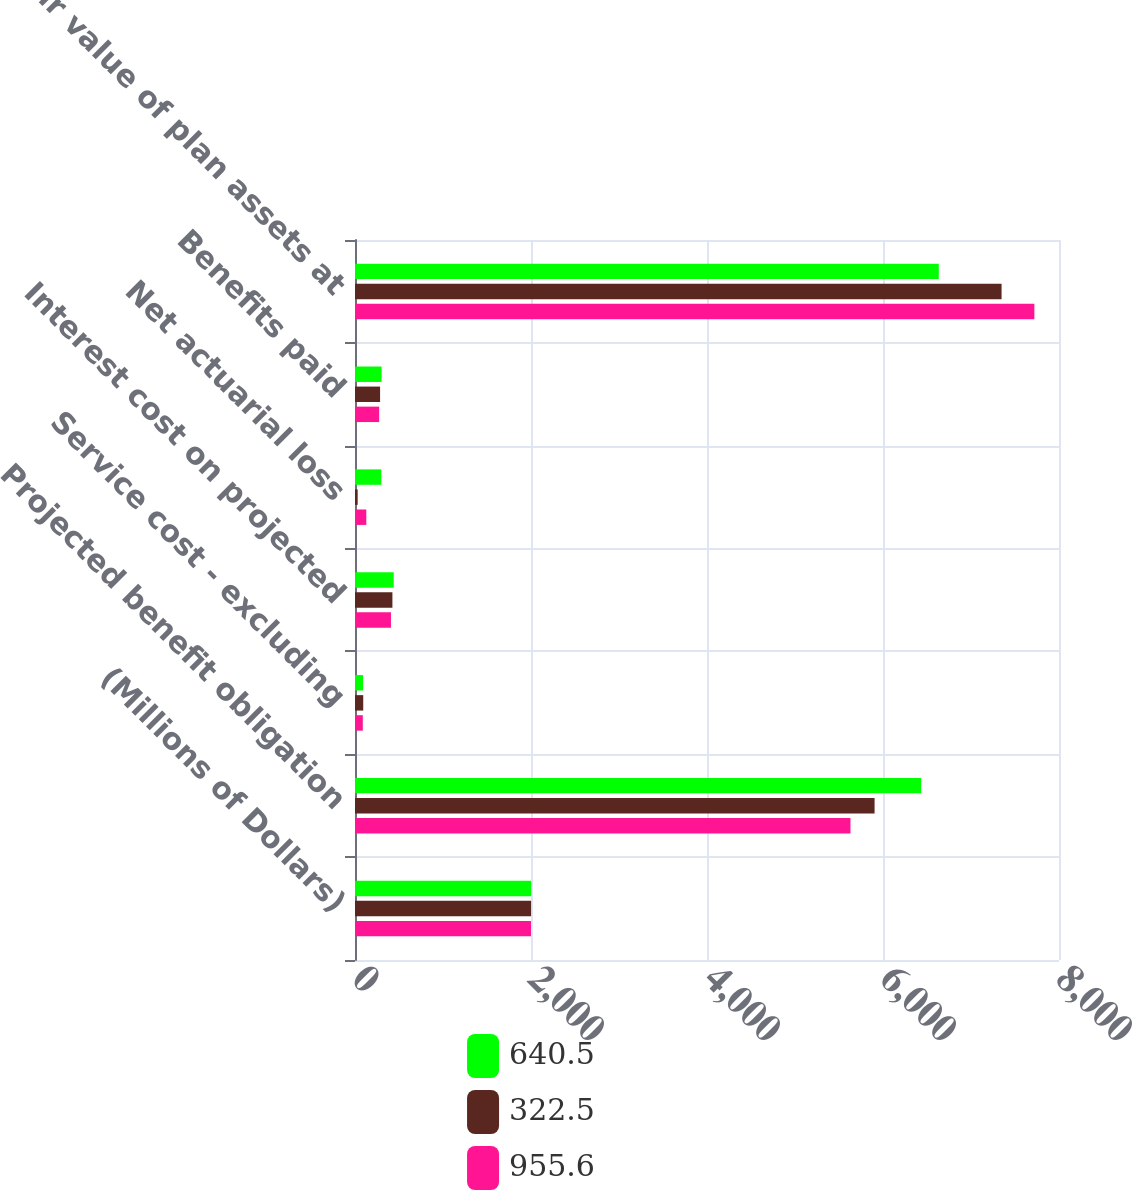Convert chart. <chart><loc_0><loc_0><loc_500><loc_500><stacked_bar_chart><ecel><fcel>(Millions of Dollars)<fcel>Projected benefit obligation<fcel>Service cost - excluding<fcel>Interest cost on projected<fcel>Net actuarial loss<fcel>Benefits paid<fcel>Fair value of plan assets at<nl><fcel>640.5<fcel>2002<fcel>6433.6<fcel>92.2<fcel>440.1<fcel>299<fcel>302<fcel>6633.7<nl><fcel>322.5<fcel>2001<fcel>5904.3<fcel>93.6<fcel>425.2<fcel>30.4<fcel>285.1<fcel>7347.5<nl><fcel>955.6<fcel>2000<fcel>5630.4<fcel>88.7<fcel>408.7<fcel>128.5<fcel>274.8<fcel>7720.1<nl></chart> 